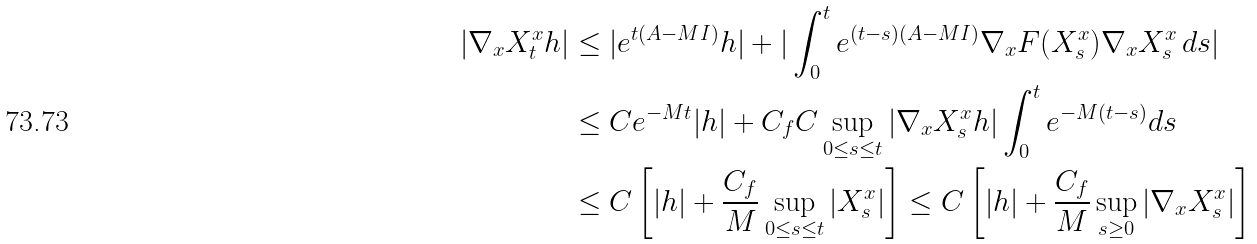Convert formula to latex. <formula><loc_0><loc_0><loc_500><loc_500>| \nabla _ { x } X _ { t } ^ { x } h | & \leq | e ^ { t ( A - M I ) } h | + | \int _ { 0 } ^ { t } e ^ { ( t - s ) ( A - M I ) } \nabla _ { x } F ( X _ { s } ^ { x } ) \nabla _ { x } X _ { s } ^ { x } \, d s | \\ & \leq C e ^ { - M t } | h | + C _ { f } C \sup _ { 0 \leq s \leq t } | \nabla _ { x } X _ { s } ^ { x } h | \int _ { 0 } ^ { t } e ^ { - M ( t - s ) } d s \\ & \leq C \left [ | h | + \frac { C _ { f } } { M } \sup _ { 0 \leq s \leq t } | X _ { s } ^ { x } | \right ] \leq C \left [ | h | + \frac { C _ { f } } { M } \sup _ { s \geq 0 } | \nabla _ { x } X _ { s } ^ { x } | \right ] \\</formula> 